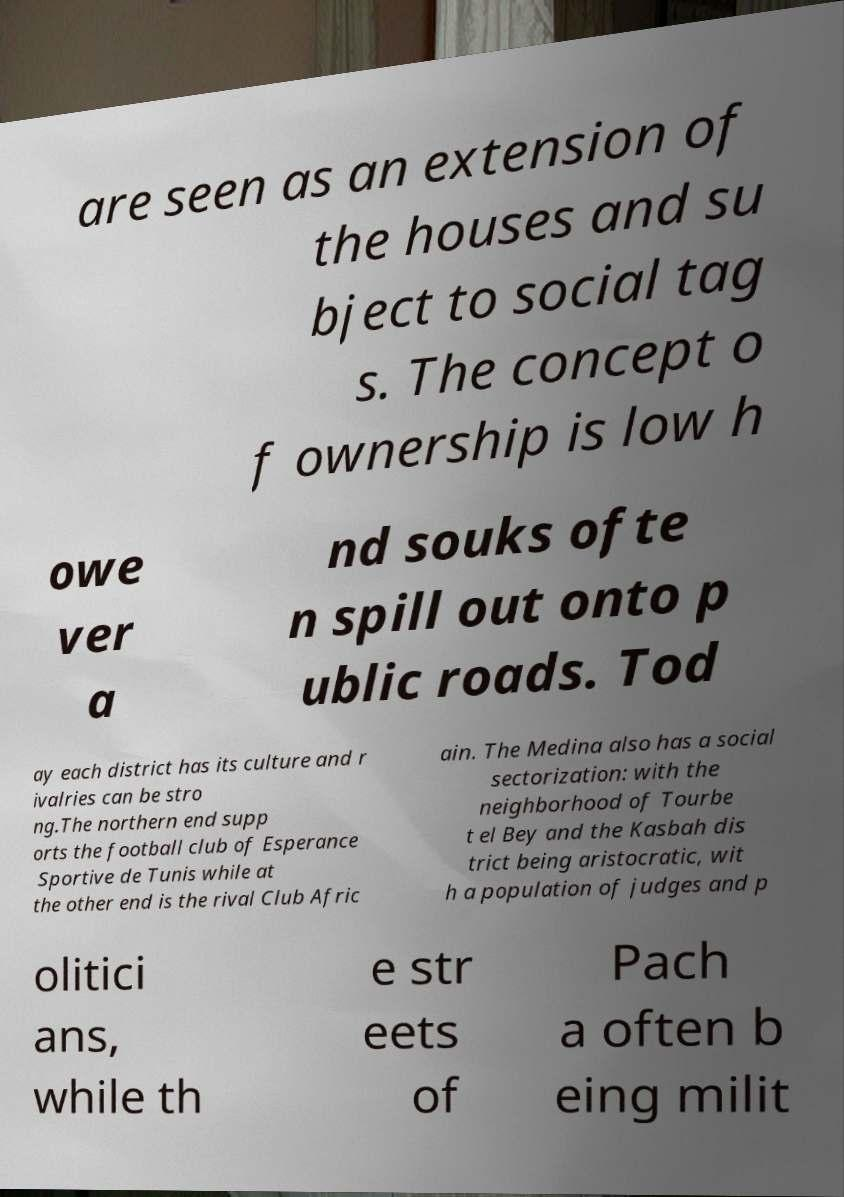Can you read and provide the text displayed in the image?This photo seems to have some interesting text. Can you extract and type it out for me? are seen as an extension of the houses and su bject to social tag s. The concept o f ownership is low h owe ver a nd souks ofte n spill out onto p ublic roads. Tod ay each district has its culture and r ivalries can be stro ng.The northern end supp orts the football club of Esperance Sportive de Tunis while at the other end is the rival Club Afric ain. The Medina also has a social sectorization: with the neighborhood of Tourbe t el Bey and the Kasbah dis trict being aristocratic, wit h a population of judges and p olitici ans, while th e str eets of Pach a often b eing milit 